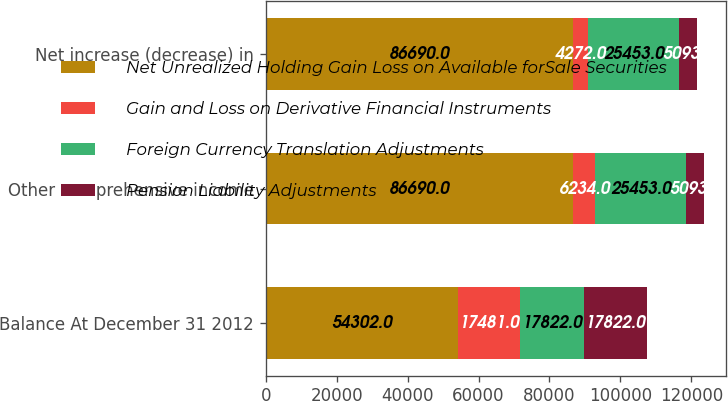<chart> <loc_0><loc_0><loc_500><loc_500><stacked_bar_chart><ecel><fcel>Balance At December 31 2012<fcel>Other comprehensive income<fcel>Net increase (decrease) in<nl><fcel>Net Unrealized Holding Gain Loss on Available forSale Securities<fcel>54302<fcel>86690<fcel>86690<nl><fcel>Gain and Loss on Derivative Financial Instruments<fcel>17481<fcel>6234<fcel>4272<nl><fcel>Foreign Currency Translation Adjustments<fcel>17822<fcel>25453<fcel>25453<nl><fcel>Pension Liability Adjustments<fcel>17822<fcel>5093<fcel>5093<nl></chart> 